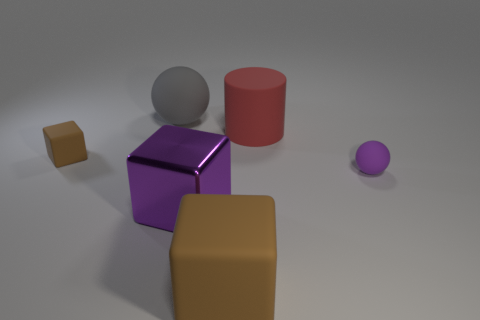Subtract all matte cubes. How many cubes are left? 1 Add 4 metal cubes. How many objects exist? 10 Subtract all brown cylinders. How many brown blocks are left? 2 Subtract all balls. How many objects are left? 4 Subtract all brown cubes. How many cubes are left? 1 Subtract 1 spheres. How many spheres are left? 1 Subtract all yellow spheres. Subtract all brown blocks. How many spheres are left? 2 Subtract all large green shiny cubes. Subtract all gray rubber objects. How many objects are left? 5 Add 5 large shiny blocks. How many large shiny blocks are left? 6 Add 1 small red things. How many small red things exist? 1 